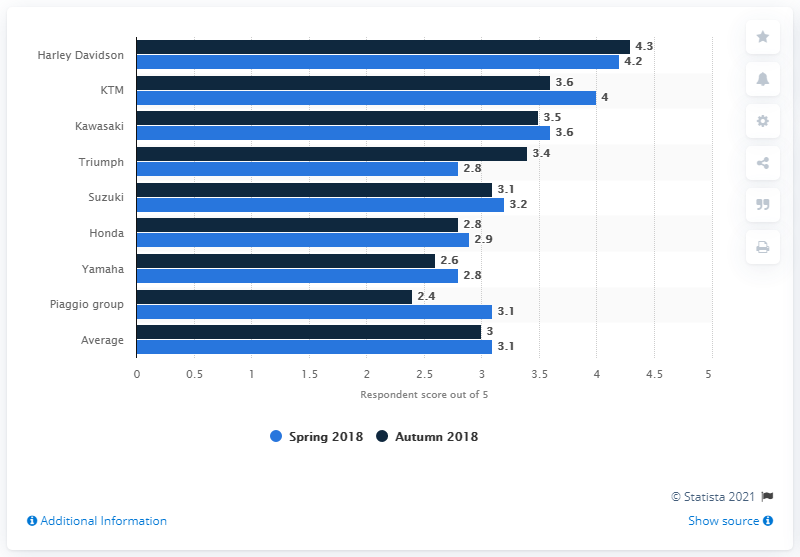Draw attention to some important aspects in this diagram. The most optimistic motorcycle dealer about the future of their business was Harley Davidson. 